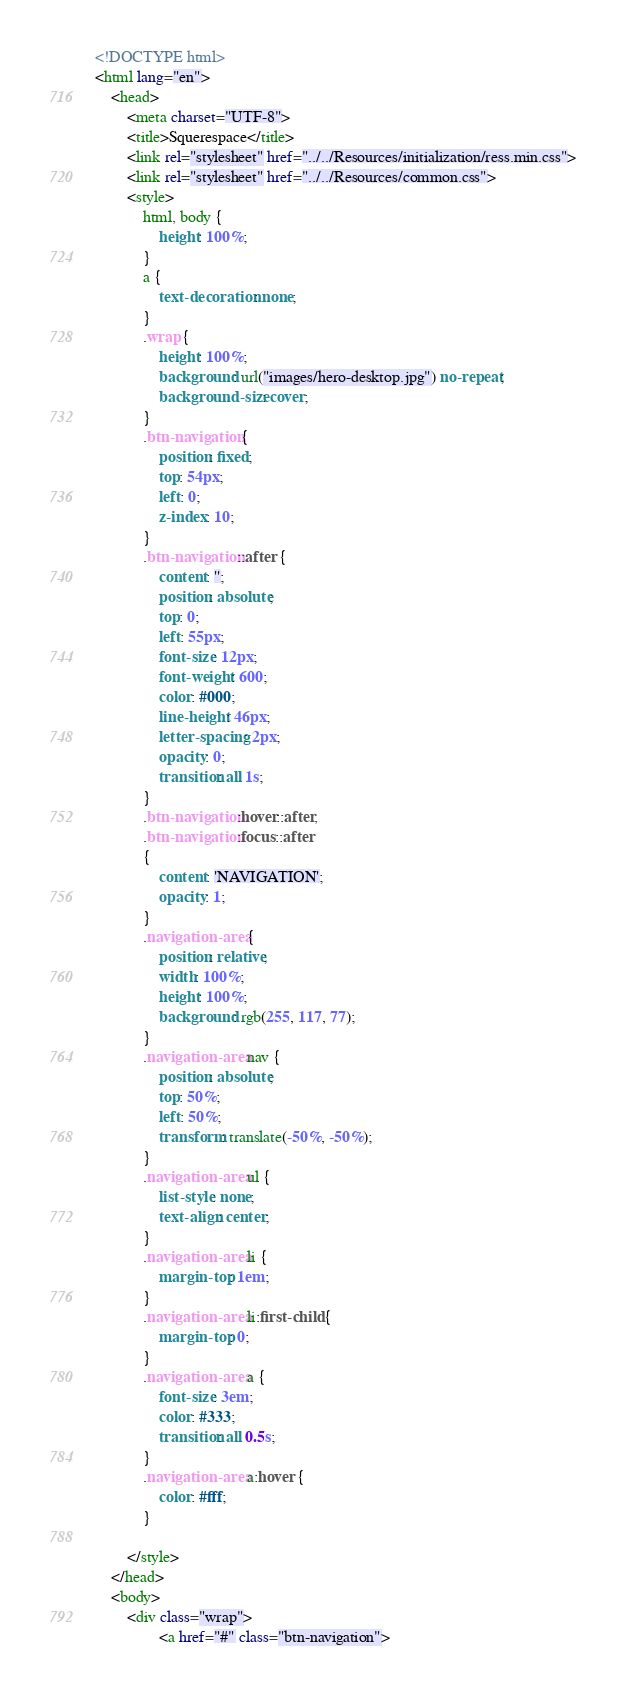<code> <loc_0><loc_0><loc_500><loc_500><_HTML_><!DOCTYPE html>
<html lang="en">
	<head>
		<meta charset="UTF-8">
		<title>Squerespace</title>
		<link rel="stylesheet" href="../../Resources/initialization/ress.min.css">
		<link rel="stylesheet" href="../../Resources/common.css">
		<style>
			html, body {
				height: 100%;
			}
			a {
				text-decoration: none;
			}
			.wrap {
				height: 100%;
				background: url("images/hero-desktop.jpg") no-repeat;
				background-size: cover;
			}
			.btn-navigation {
				position: fixed;
				top: 54px;
				left: 0;
				z-index: 10;
			}
			.btn-navigation::after {
				content: '';
				position: absolute;
				top: 0;
				left: 55px;
				font-size: 12px;
				font-weight: 600;
				color: #000;
				line-height: 46px;
				letter-spacing: 2px;
				opacity: 0;
				transition: all 1s;
			}
			.btn-navigation:hover::after,
			.btn-navigation:focus::after
			{
				content: 'NAVIGATION';
				opacity: 1;
			}
			.navigation-area {
				position: relative;
				width: 100%;
				height: 100%;
				background: rgb(255, 117, 77);
			}
			.navigation-area nav {
				position: absolute;
				top: 50%;
				left: 50%;
				transform: translate(-50%, -50%);
			}
			.navigation-area ul {
				list-style: none;
				text-align: center;
			}
			.navigation-area li {
				margin-top: 1em;
			}
			.navigation-area li:first-child {
				margin-top: 0;
			}
			.navigation-area a {
				font-size: 3em;
				color: #333;
				transition: all 0.5s;
			}
			.navigation-area a:hover {
				color: #fff;
			}
			
		</style>
	</head>
	<body>
		<div class="wrap">
				<a href="#" class="btn-navigation"></code> 